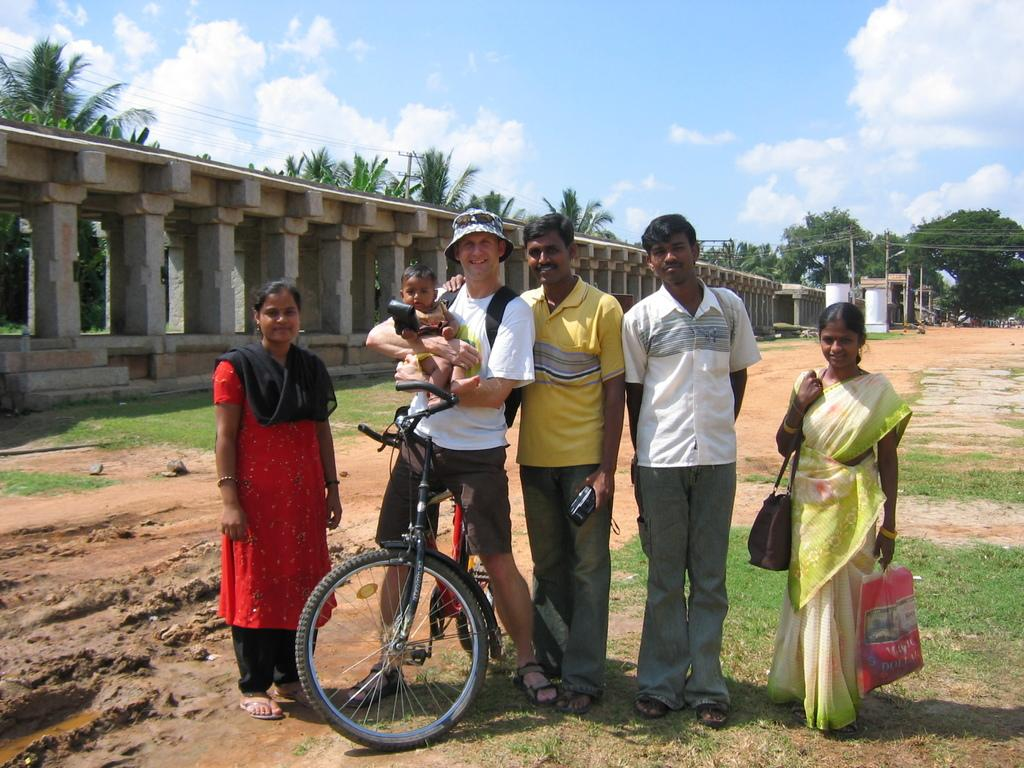What can be seen in the background of the image? There is a sky in the image. What is present in the sky? There are clouds in the image. What structure is visible in the image? There is a bridge in the image. What type of natural vegetation is present in the image? There are trees in the image. Who or what is present in the image? There are people standing in the image. How do the people in the image receive the latest news? There is no indication in the image of how the people receive news, as the image does not depict any news sources or devices. 